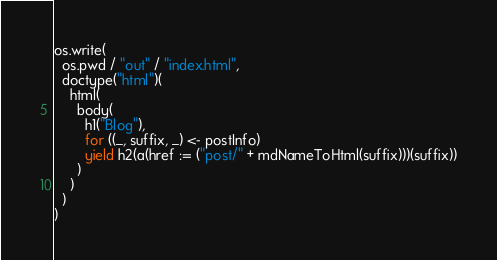<code> <loc_0><loc_0><loc_500><loc_500><_Scala_>os.write(
  os.pwd / "out" / "index.html",
  doctype("html")(
    html(
      body(
        h1("Blog"),
        for ((_, suffix, _) <- postInfo)
        yield h2(a(href := ("post/" + mdNameToHtml(suffix)))(suffix))
      )
    )
  )
)
</code> 